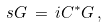<formula> <loc_0><loc_0><loc_500><loc_500>s G \, = \, i C ^ { * } G \, ,</formula> 